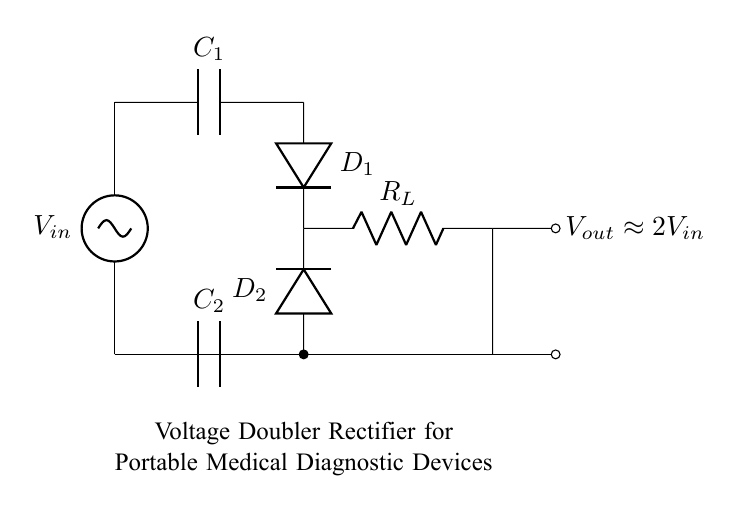What is the input voltage denoted as in this circuit? The input voltage is represented as \( V_{in} \), which is the point where the voltage source connects to the rectifier circuit.
Answer: V sub in What type of capacitors are present in this circuit? The circuit shows two capacitors, \( C_1 \) and \( C_2 \), both denoted by the symbol for capacitors in circuit diagrams.
Answer: Capacitors What is the expected output voltage roughly equal to? The output voltage \( V_{out} \) is specified as approximately \( 2V_{in} \), indicating that the output voltage is expected to be double the input voltage.
Answer: Approximately 2 times V sub in How many diodes are used in this voltage doubler circuit? The circuit contains two diodes, labeled as \( D_1 \) and \( D_2 \), which are integral for the rectification process.
Answer: Two Which component is responsible for smoothing the output voltage? The capacitor \( C_2 \) is positioned in the circuit to smoothen the output voltage by filtering any fluctuations after rectification.
Answer: Capacitor C sub 2 Why is this circuit referred to as a voltage doubler? The circuit is classified as a voltage doubler because it utilizes two capacitors and diodes to convert an input AC voltage to an output voltage that is approximately double the input, indicated by the output label.
Answer: Because it doubles the voltage 